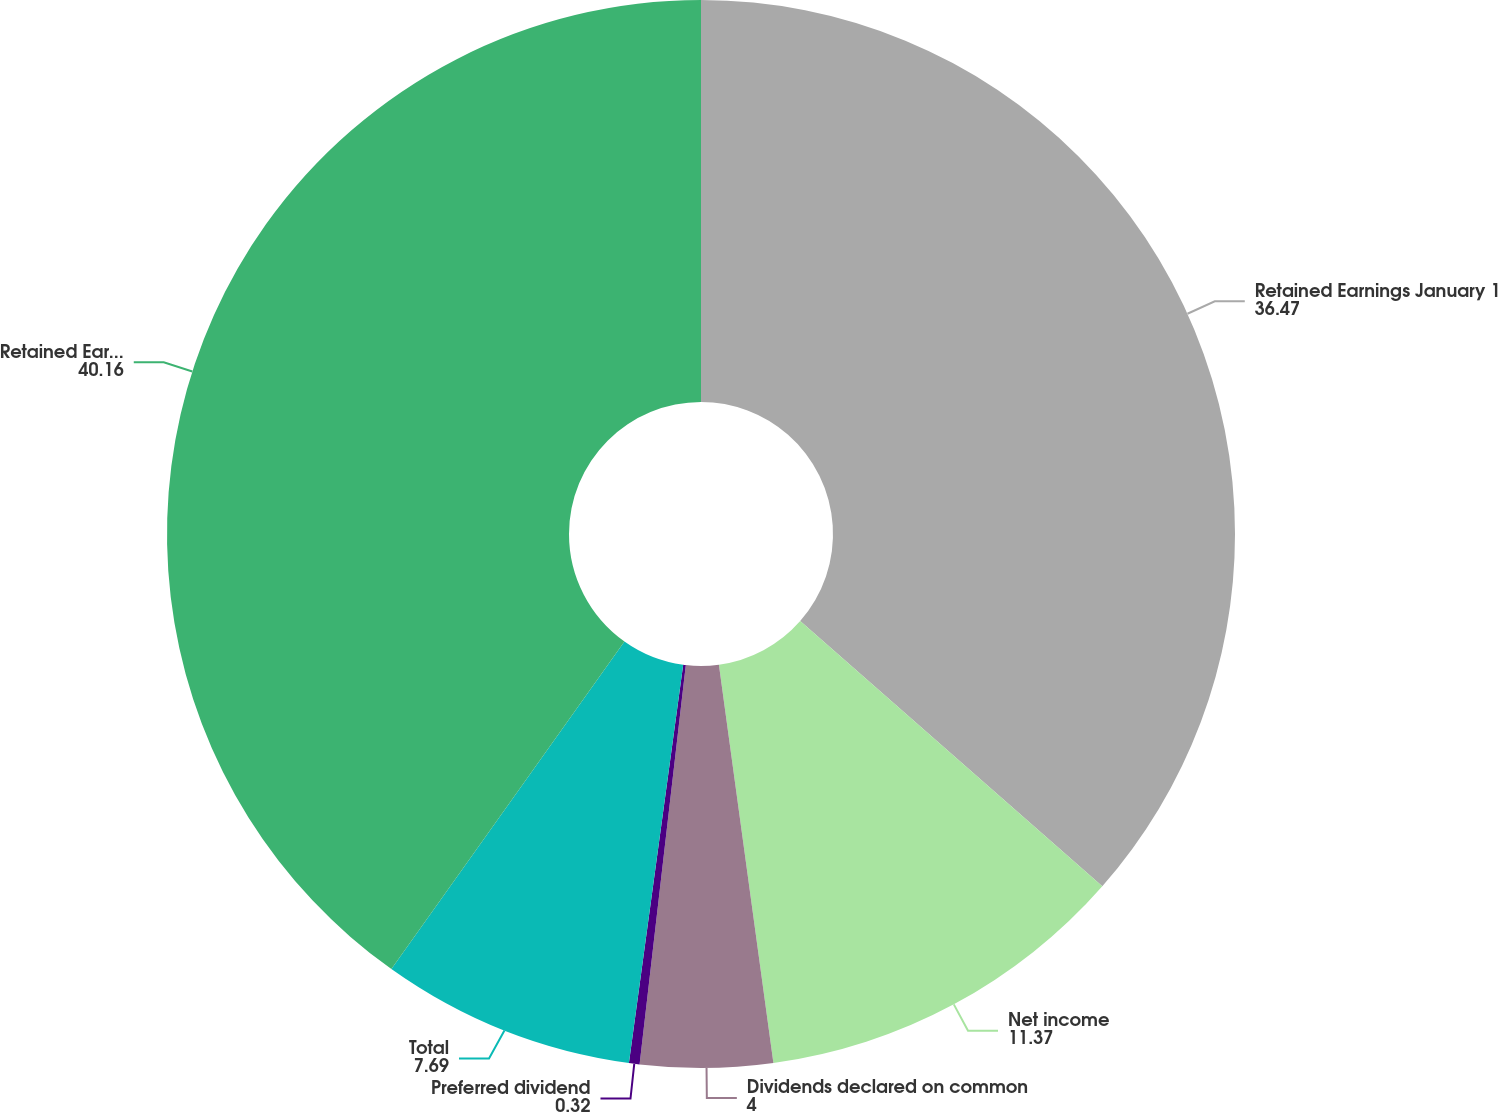<chart> <loc_0><loc_0><loc_500><loc_500><pie_chart><fcel>Retained Earnings January 1<fcel>Net income<fcel>Dividends declared on common<fcel>Preferred dividend<fcel>Total<fcel>Retained Earnings December 31<nl><fcel>36.47%<fcel>11.37%<fcel>4.0%<fcel>0.32%<fcel>7.69%<fcel>40.16%<nl></chart> 